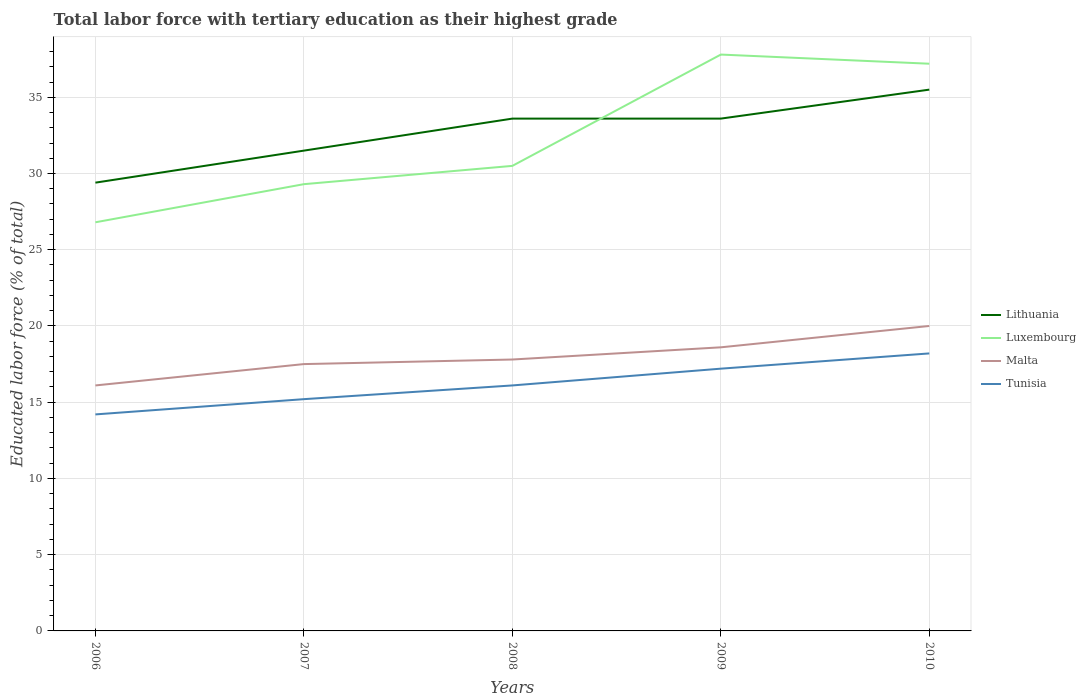How many different coloured lines are there?
Offer a very short reply. 4. Is the number of lines equal to the number of legend labels?
Ensure brevity in your answer.  Yes. Across all years, what is the maximum percentage of male labor force with tertiary education in Luxembourg?
Make the answer very short. 26.8. In which year was the percentage of male labor force with tertiary education in Luxembourg maximum?
Provide a succinct answer. 2006. What is the total percentage of male labor force with tertiary education in Tunisia in the graph?
Ensure brevity in your answer.  -3. What is the difference between the highest and the second highest percentage of male labor force with tertiary education in Malta?
Make the answer very short. 3.9. How many lines are there?
Provide a succinct answer. 4. What is the difference between two consecutive major ticks on the Y-axis?
Your response must be concise. 5. Are the values on the major ticks of Y-axis written in scientific E-notation?
Make the answer very short. No. Does the graph contain any zero values?
Your response must be concise. No. How many legend labels are there?
Offer a very short reply. 4. How are the legend labels stacked?
Your response must be concise. Vertical. What is the title of the graph?
Make the answer very short. Total labor force with tertiary education as their highest grade. What is the label or title of the Y-axis?
Offer a very short reply. Educated labor force (% of total). What is the Educated labor force (% of total) in Lithuania in 2006?
Your answer should be very brief. 29.4. What is the Educated labor force (% of total) in Luxembourg in 2006?
Your answer should be compact. 26.8. What is the Educated labor force (% of total) of Malta in 2006?
Offer a terse response. 16.1. What is the Educated labor force (% of total) in Tunisia in 2006?
Offer a terse response. 14.2. What is the Educated labor force (% of total) of Lithuania in 2007?
Your response must be concise. 31.5. What is the Educated labor force (% of total) of Luxembourg in 2007?
Provide a succinct answer. 29.3. What is the Educated labor force (% of total) in Malta in 2007?
Provide a succinct answer. 17.5. What is the Educated labor force (% of total) of Tunisia in 2007?
Keep it short and to the point. 15.2. What is the Educated labor force (% of total) in Lithuania in 2008?
Offer a terse response. 33.6. What is the Educated labor force (% of total) in Luxembourg in 2008?
Your response must be concise. 30.5. What is the Educated labor force (% of total) in Malta in 2008?
Keep it short and to the point. 17.8. What is the Educated labor force (% of total) in Tunisia in 2008?
Provide a succinct answer. 16.1. What is the Educated labor force (% of total) in Lithuania in 2009?
Provide a short and direct response. 33.6. What is the Educated labor force (% of total) of Luxembourg in 2009?
Offer a very short reply. 37.8. What is the Educated labor force (% of total) of Malta in 2009?
Your answer should be very brief. 18.6. What is the Educated labor force (% of total) of Tunisia in 2009?
Your answer should be compact. 17.2. What is the Educated labor force (% of total) of Lithuania in 2010?
Your answer should be very brief. 35.5. What is the Educated labor force (% of total) in Luxembourg in 2010?
Provide a short and direct response. 37.2. What is the Educated labor force (% of total) of Tunisia in 2010?
Offer a very short reply. 18.2. Across all years, what is the maximum Educated labor force (% of total) in Lithuania?
Give a very brief answer. 35.5. Across all years, what is the maximum Educated labor force (% of total) in Luxembourg?
Your answer should be compact. 37.8. Across all years, what is the maximum Educated labor force (% of total) of Tunisia?
Provide a succinct answer. 18.2. Across all years, what is the minimum Educated labor force (% of total) of Lithuania?
Offer a very short reply. 29.4. Across all years, what is the minimum Educated labor force (% of total) of Luxembourg?
Offer a terse response. 26.8. Across all years, what is the minimum Educated labor force (% of total) of Malta?
Your response must be concise. 16.1. Across all years, what is the minimum Educated labor force (% of total) of Tunisia?
Provide a short and direct response. 14.2. What is the total Educated labor force (% of total) in Lithuania in the graph?
Give a very brief answer. 163.6. What is the total Educated labor force (% of total) in Luxembourg in the graph?
Provide a short and direct response. 161.6. What is the total Educated labor force (% of total) of Tunisia in the graph?
Offer a very short reply. 80.9. What is the difference between the Educated labor force (% of total) in Lithuania in 2006 and that in 2007?
Provide a short and direct response. -2.1. What is the difference between the Educated labor force (% of total) in Malta in 2006 and that in 2007?
Give a very brief answer. -1.4. What is the difference between the Educated labor force (% of total) in Tunisia in 2006 and that in 2007?
Offer a very short reply. -1. What is the difference between the Educated labor force (% of total) of Lithuania in 2006 and that in 2008?
Your answer should be very brief. -4.2. What is the difference between the Educated labor force (% of total) in Luxembourg in 2006 and that in 2008?
Give a very brief answer. -3.7. What is the difference between the Educated labor force (% of total) of Tunisia in 2006 and that in 2008?
Give a very brief answer. -1.9. What is the difference between the Educated labor force (% of total) of Luxembourg in 2006 and that in 2009?
Your response must be concise. -11. What is the difference between the Educated labor force (% of total) in Malta in 2006 and that in 2009?
Your response must be concise. -2.5. What is the difference between the Educated labor force (% of total) of Tunisia in 2006 and that in 2009?
Give a very brief answer. -3. What is the difference between the Educated labor force (% of total) in Lithuania in 2006 and that in 2010?
Keep it short and to the point. -6.1. What is the difference between the Educated labor force (% of total) in Luxembourg in 2006 and that in 2010?
Ensure brevity in your answer.  -10.4. What is the difference between the Educated labor force (% of total) in Tunisia in 2006 and that in 2010?
Your answer should be very brief. -4. What is the difference between the Educated labor force (% of total) in Lithuania in 2007 and that in 2008?
Provide a short and direct response. -2.1. What is the difference between the Educated labor force (% of total) in Luxembourg in 2007 and that in 2008?
Ensure brevity in your answer.  -1.2. What is the difference between the Educated labor force (% of total) of Malta in 2007 and that in 2008?
Your answer should be compact. -0.3. What is the difference between the Educated labor force (% of total) in Tunisia in 2007 and that in 2008?
Offer a very short reply. -0.9. What is the difference between the Educated labor force (% of total) of Luxembourg in 2007 and that in 2009?
Provide a succinct answer. -8.5. What is the difference between the Educated labor force (% of total) of Lithuania in 2007 and that in 2010?
Your response must be concise. -4. What is the difference between the Educated labor force (% of total) in Malta in 2007 and that in 2010?
Provide a short and direct response. -2.5. What is the difference between the Educated labor force (% of total) of Tunisia in 2007 and that in 2010?
Make the answer very short. -3. What is the difference between the Educated labor force (% of total) of Lithuania in 2008 and that in 2009?
Provide a succinct answer. 0. What is the difference between the Educated labor force (% of total) of Luxembourg in 2008 and that in 2009?
Offer a very short reply. -7.3. What is the difference between the Educated labor force (% of total) in Malta in 2008 and that in 2009?
Your response must be concise. -0.8. What is the difference between the Educated labor force (% of total) of Luxembourg in 2008 and that in 2010?
Your answer should be very brief. -6.7. What is the difference between the Educated labor force (% of total) of Luxembourg in 2009 and that in 2010?
Provide a short and direct response. 0.6. What is the difference between the Educated labor force (% of total) of Malta in 2009 and that in 2010?
Make the answer very short. -1.4. What is the difference between the Educated labor force (% of total) of Tunisia in 2009 and that in 2010?
Offer a very short reply. -1. What is the difference between the Educated labor force (% of total) in Lithuania in 2006 and the Educated labor force (% of total) in Tunisia in 2007?
Your answer should be compact. 14.2. What is the difference between the Educated labor force (% of total) of Luxembourg in 2006 and the Educated labor force (% of total) of Tunisia in 2007?
Keep it short and to the point. 11.6. What is the difference between the Educated labor force (% of total) in Malta in 2006 and the Educated labor force (% of total) in Tunisia in 2007?
Your answer should be very brief. 0.9. What is the difference between the Educated labor force (% of total) of Luxembourg in 2006 and the Educated labor force (% of total) of Malta in 2008?
Your answer should be very brief. 9. What is the difference between the Educated labor force (% of total) in Luxembourg in 2006 and the Educated labor force (% of total) in Tunisia in 2008?
Give a very brief answer. 10.7. What is the difference between the Educated labor force (% of total) in Lithuania in 2006 and the Educated labor force (% of total) in Luxembourg in 2009?
Your response must be concise. -8.4. What is the difference between the Educated labor force (% of total) in Luxembourg in 2006 and the Educated labor force (% of total) in Tunisia in 2009?
Offer a terse response. 9.6. What is the difference between the Educated labor force (% of total) in Malta in 2006 and the Educated labor force (% of total) in Tunisia in 2009?
Provide a short and direct response. -1.1. What is the difference between the Educated labor force (% of total) of Lithuania in 2006 and the Educated labor force (% of total) of Malta in 2010?
Keep it short and to the point. 9.4. What is the difference between the Educated labor force (% of total) of Malta in 2006 and the Educated labor force (% of total) of Tunisia in 2010?
Provide a short and direct response. -2.1. What is the difference between the Educated labor force (% of total) of Lithuania in 2007 and the Educated labor force (% of total) of Luxembourg in 2008?
Give a very brief answer. 1. What is the difference between the Educated labor force (% of total) in Lithuania in 2007 and the Educated labor force (% of total) in Tunisia in 2008?
Your response must be concise. 15.4. What is the difference between the Educated labor force (% of total) of Luxembourg in 2007 and the Educated labor force (% of total) of Malta in 2008?
Your response must be concise. 11.5. What is the difference between the Educated labor force (% of total) of Luxembourg in 2007 and the Educated labor force (% of total) of Tunisia in 2008?
Ensure brevity in your answer.  13.2. What is the difference between the Educated labor force (% of total) of Lithuania in 2007 and the Educated labor force (% of total) of Luxembourg in 2009?
Ensure brevity in your answer.  -6.3. What is the difference between the Educated labor force (% of total) of Luxembourg in 2007 and the Educated labor force (% of total) of Tunisia in 2009?
Keep it short and to the point. 12.1. What is the difference between the Educated labor force (% of total) in Lithuania in 2007 and the Educated labor force (% of total) in Luxembourg in 2010?
Give a very brief answer. -5.7. What is the difference between the Educated labor force (% of total) of Lithuania in 2007 and the Educated labor force (% of total) of Malta in 2010?
Give a very brief answer. 11.5. What is the difference between the Educated labor force (% of total) in Lithuania in 2007 and the Educated labor force (% of total) in Tunisia in 2010?
Ensure brevity in your answer.  13.3. What is the difference between the Educated labor force (% of total) in Luxembourg in 2007 and the Educated labor force (% of total) in Malta in 2010?
Give a very brief answer. 9.3. What is the difference between the Educated labor force (% of total) of Malta in 2007 and the Educated labor force (% of total) of Tunisia in 2010?
Your answer should be compact. -0.7. What is the difference between the Educated labor force (% of total) of Lithuania in 2008 and the Educated labor force (% of total) of Luxembourg in 2009?
Your response must be concise. -4.2. What is the difference between the Educated labor force (% of total) in Luxembourg in 2008 and the Educated labor force (% of total) in Malta in 2009?
Offer a very short reply. 11.9. What is the difference between the Educated labor force (% of total) of Malta in 2008 and the Educated labor force (% of total) of Tunisia in 2009?
Ensure brevity in your answer.  0.6. What is the difference between the Educated labor force (% of total) of Lithuania in 2008 and the Educated labor force (% of total) of Malta in 2010?
Make the answer very short. 13.6. What is the difference between the Educated labor force (% of total) in Lithuania in 2008 and the Educated labor force (% of total) in Tunisia in 2010?
Provide a succinct answer. 15.4. What is the difference between the Educated labor force (% of total) in Luxembourg in 2008 and the Educated labor force (% of total) in Malta in 2010?
Give a very brief answer. 10.5. What is the difference between the Educated labor force (% of total) in Luxembourg in 2008 and the Educated labor force (% of total) in Tunisia in 2010?
Provide a short and direct response. 12.3. What is the difference between the Educated labor force (% of total) of Malta in 2008 and the Educated labor force (% of total) of Tunisia in 2010?
Your answer should be compact. -0.4. What is the difference between the Educated labor force (% of total) in Lithuania in 2009 and the Educated labor force (% of total) in Luxembourg in 2010?
Keep it short and to the point. -3.6. What is the difference between the Educated labor force (% of total) of Lithuania in 2009 and the Educated labor force (% of total) of Malta in 2010?
Your response must be concise. 13.6. What is the difference between the Educated labor force (% of total) of Luxembourg in 2009 and the Educated labor force (% of total) of Tunisia in 2010?
Your response must be concise. 19.6. What is the average Educated labor force (% of total) of Lithuania per year?
Your answer should be very brief. 32.72. What is the average Educated labor force (% of total) of Luxembourg per year?
Make the answer very short. 32.32. What is the average Educated labor force (% of total) of Tunisia per year?
Offer a very short reply. 16.18. In the year 2006, what is the difference between the Educated labor force (% of total) in Lithuania and Educated labor force (% of total) in Luxembourg?
Your answer should be compact. 2.6. In the year 2007, what is the difference between the Educated labor force (% of total) in Lithuania and Educated labor force (% of total) in Tunisia?
Give a very brief answer. 16.3. In the year 2007, what is the difference between the Educated labor force (% of total) of Luxembourg and Educated labor force (% of total) of Tunisia?
Provide a succinct answer. 14.1. In the year 2008, what is the difference between the Educated labor force (% of total) of Lithuania and Educated labor force (% of total) of Luxembourg?
Make the answer very short. 3.1. In the year 2008, what is the difference between the Educated labor force (% of total) in Malta and Educated labor force (% of total) in Tunisia?
Ensure brevity in your answer.  1.7. In the year 2009, what is the difference between the Educated labor force (% of total) of Lithuania and Educated labor force (% of total) of Luxembourg?
Provide a succinct answer. -4.2. In the year 2009, what is the difference between the Educated labor force (% of total) of Lithuania and Educated labor force (% of total) of Malta?
Your answer should be very brief. 15. In the year 2009, what is the difference between the Educated labor force (% of total) of Lithuania and Educated labor force (% of total) of Tunisia?
Give a very brief answer. 16.4. In the year 2009, what is the difference between the Educated labor force (% of total) of Luxembourg and Educated labor force (% of total) of Malta?
Your answer should be compact. 19.2. In the year 2009, what is the difference between the Educated labor force (% of total) of Luxembourg and Educated labor force (% of total) of Tunisia?
Your answer should be compact. 20.6. In the year 2010, what is the difference between the Educated labor force (% of total) of Lithuania and Educated labor force (% of total) of Luxembourg?
Offer a very short reply. -1.7. In the year 2010, what is the difference between the Educated labor force (% of total) in Lithuania and Educated labor force (% of total) in Malta?
Your answer should be very brief. 15.5. What is the ratio of the Educated labor force (% of total) of Luxembourg in 2006 to that in 2007?
Your answer should be compact. 0.91. What is the ratio of the Educated labor force (% of total) of Malta in 2006 to that in 2007?
Offer a terse response. 0.92. What is the ratio of the Educated labor force (% of total) in Tunisia in 2006 to that in 2007?
Provide a succinct answer. 0.93. What is the ratio of the Educated labor force (% of total) in Luxembourg in 2006 to that in 2008?
Your answer should be very brief. 0.88. What is the ratio of the Educated labor force (% of total) of Malta in 2006 to that in 2008?
Your answer should be compact. 0.9. What is the ratio of the Educated labor force (% of total) in Tunisia in 2006 to that in 2008?
Give a very brief answer. 0.88. What is the ratio of the Educated labor force (% of total) in Lithuania in 2006 to that in 2009?
Your response must be concise. 0.88. What is the ratio of the Educated labor force (% of total) of Luxembourg in 2006 to that in 2009?
Provide a succinct answer. 0.71. What is the ratio of the Educated labor force (% of total) in Malta in 2006 to that in 2009?
Make the answer very short. 0.87. What is the ratio of the Educated labor force (% of total) of Tunisia in 2006 to that in 2009?
Give a very brief answer. 0.83. What is the ratio of the Educated labor force (% of total) of Lithuania in 2006 to that in 2010?
Your answer should be compact. 0.83. What is the ratio of the Educated labor force (% of total) in Luxembourg in 2006 to that in 2010?
Provide a succinct answer. 0.72. What is the ratio of the Educated labor force (% of total) in Malta in 2006 to that in 2010?
Make the answer very short. 0.81. What is the ratio of the Educated labor force (% of total) in Tunisia in 2006 to that in 2010?
Ensure brevity in your answer.  0.78. What is the ratio of the Educated labor force (% of total) of Lithuania in 2007 to that in 2008?
Provide a succinct answer. 0.94. What is the ratio of the Educated labor force (% of total) in Luxembourg in 2007 to that in 2008?
Provide a succinct answer. 0.96. What is the ratio of the Educated labor force (% of total) of Malta in 2007 to that in 2008?
Keep it short and to the point. 0.98. What is the ratio of the Educated labor force (% of total) of Tunisia in 2007 to that in 2008?
Make the answer very short. 0.94. What is the ratio of the Educated labor force (% of total) in Lithuania in 2007 to that in 2009?
Offer a very short reply. 0.94. What is the ratio of the Educated labor force (% of total) of Luxembourg in 2007 to that in 2009?
Make the answer very short. 0.78. What is the ratio of the Educated labor force (% of total) in Malta in 2007 to that in 2009?
Ensure brevity in your answer.  0.94. What is the ratio of the Educated labor force (% of total) of Tunisia in 2007 to that in 2009?
Offer a very short reply. 0.88. What is the ratio of the Educated labor force (% of total) in Lithuania in 2007 to that in 2010?
Make the answer very short. 0.89. What is the ratio of the Educated labor force (% of total) in Luxembourg in 2007 to that in 2010?
Give a very brief answer. 0.79. What is the ratio of the Educated labor force (% of total) of Tunisia in 2007 to that in 2010?
Ensure brevity in your answer.  0.84. What is the ratio of the Educated labor force (% of total) in Luxembourg in 2008 to that in 2009?
Ensure brevity in your answer.  0.81. What is the ratio of the Educated labor force (% of total) of Tunisia in 2008 to that in 2009?
Provide a short and direct response. 0.94. What is the ratio of the Educated labor force (% of total) of Lithuania in 2008 to that in 2010?
Your answer should be very brief. 0.95. What is the ratio of the Educated labor force (% of total) of Luxembourg in 2008 to that in 2010?
Make the answer very short. 0.82. What is the ratio of the Educated labor force (% of total) in Malta in 2008 to that in 2010?
Keep it short and to the point. 0.89. What is the ratio of the Educated labor force (% of total) in Tunisia in 2008 to that in 2010?
Provide a succinct answer. 0.88. What is the ratio of the Educated labor force (% of total) of Lithuania in 2009 to that in 2010?
Offer a terse response. 0.95. What is the ratio of the Educated labor force (% of total) of Luxembourg in 2009 to that in 2010?
Your answer should be compact. 1.02. What is the ratio of the Educated labor force (% of total) in Tunisia in 2009 to that in 2010?
Your answer should be very brief. 0.95. What is the difference between the highest and the second highest Educated labor force (% of total) of Lithuania?
Keep it short and to the point. 1.9. What is the difference between the highest and the second highest Educated labor force (% of total) in Luxembourg?
Keep it short and to the point. 0.6. 